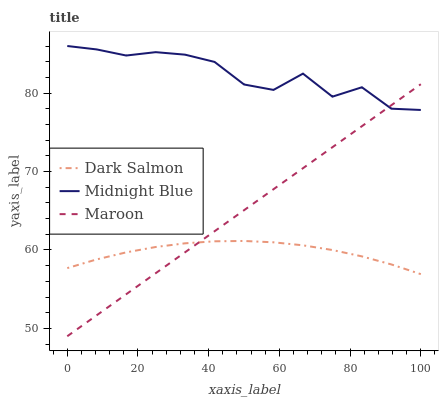Does Dark Salmon have the minimum area under the curve?
Answer yes or no. Yes. Does Midnight Blue have the maximum area under the curve?
Answer yes or no. Yes. Does Maroon have the minimum area under the curve?
Answer yes or no. No. Does Maroon have the maximum area under the curve?
Answer yes or no. No. Is Maroon the smoothest?
Answer yes or no. Yes. Is Midnight Blue the roughest?
Answer yes or no. Yes. Is Midnight Blue the smoothest?
Answer yes or no. No. Is Maroon the roughest?
Answer yes or no. No. Does Midnight Blue have the lowest value?
Answer yes or no. No. Does Midnight Blue have the highest value?
Answer yes or no. Yes. Does Maroon have the highest value?
Answer yes or no. No. Is Dark Salmon less than Midnight Blue?
Answer yes or no. Yes. Is Midnight Blue greater than Dark Salmon?
Answer yes or no. Yes. Does Dark Salmon intersect Midnight Blue?
Answer yes or no. No. 